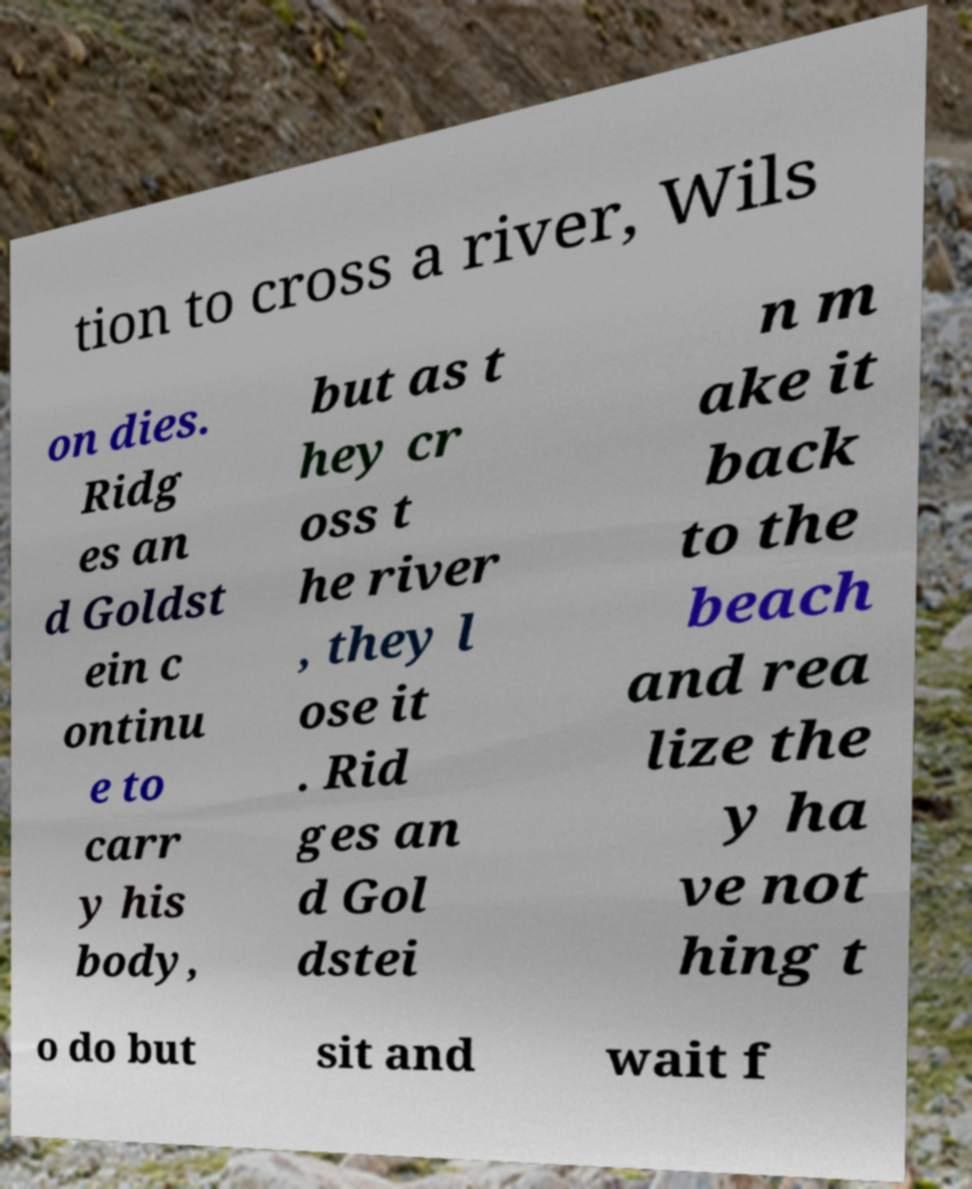Could you extract and type out the text from this image? tion to cross a river, Wils on dies. Ridg es an d Goldst ein c ontinu e to carr y his body, but as t hey cr oss t he river , they l ose it . Rid ges an d Gol dstei n m ake it back to the beach and rea lize the y ha ve not hing t o do but sit and wait f 